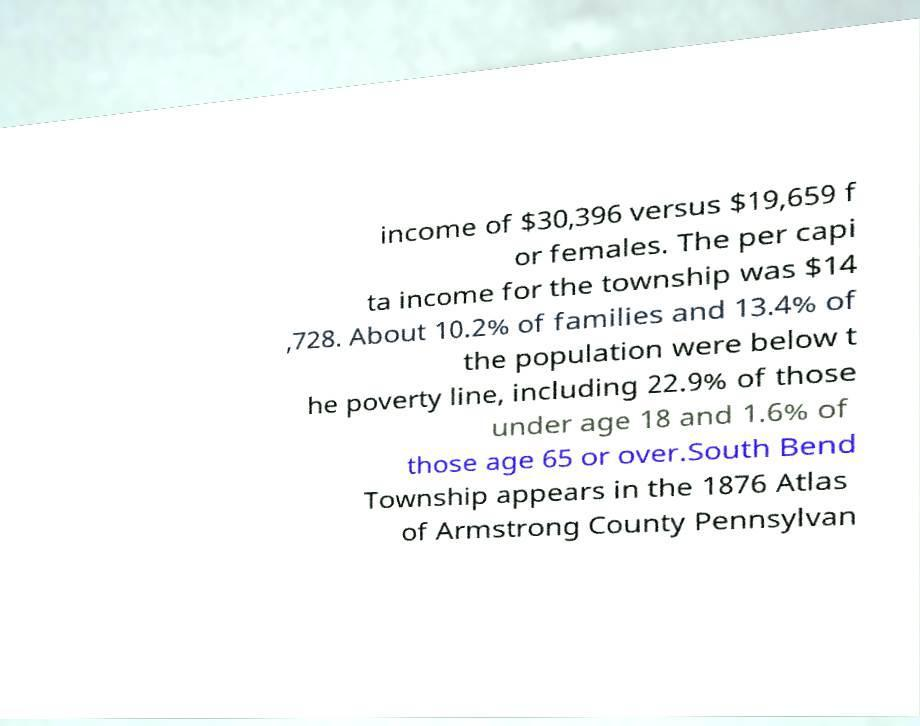I need the written content from this picture converted into text. Can you do that? income of $30,396 versus $19,659 f or females. The per capi ta income for the township was $14 ,728. About 10.2% of families and 13.4% of the population were below t he poverty line, including 22.9% of those under age 18 and 1.6% of those age 65 or over.South Bend Township appears in the 1876 Atlas of Armstrong County Pennsylvan 